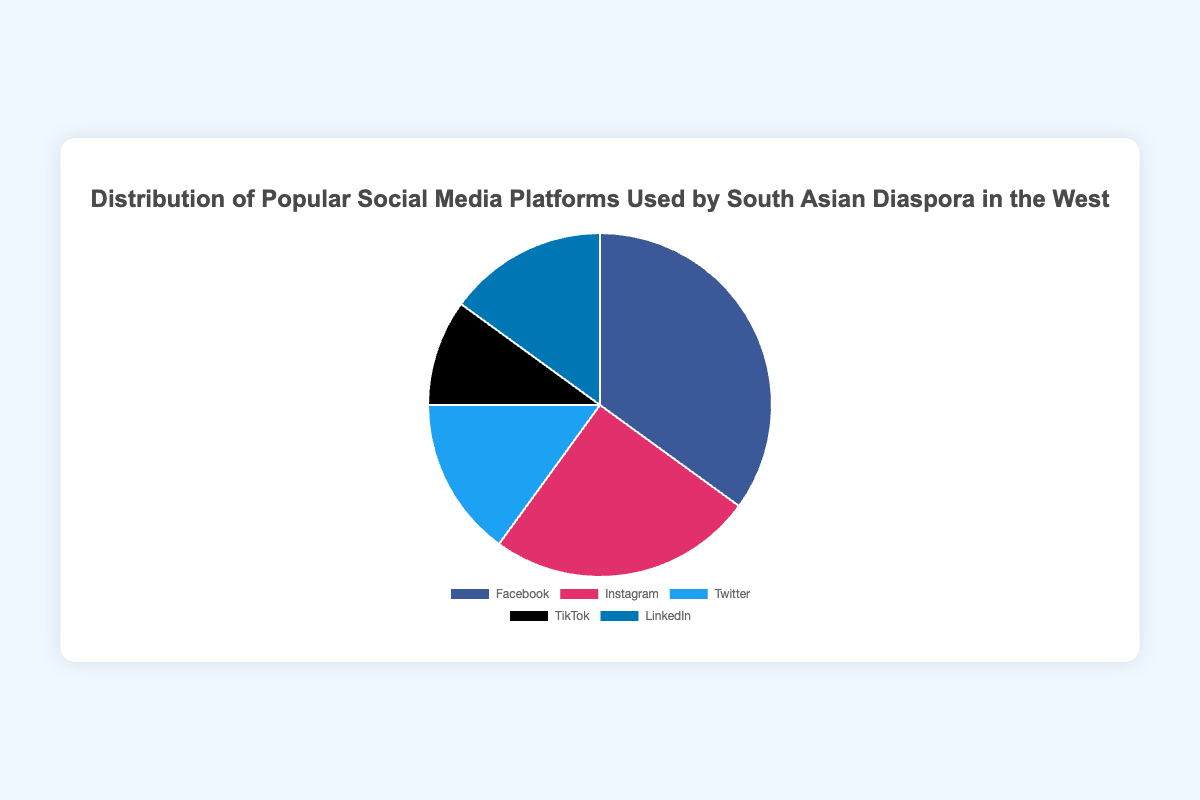What's the distribution of social media platforms in the pie chart? To find the distribution, we look at the percentage values shown in the pie chart for each platform: Facebook (35%), Instagram (25%), Twitter (15%), TikTok (10%), and LinkedIn (15%)
Answer: Facebook: 35%, Instagram: 25%, Twitter: 15%, TikTok: 10%, LinkedIn: 15% Which social media platform is the most popular among the South Asian diaspora in the West? The platform with the largest percentage slice in the pie chart is Facebook
Answer: Facebook What is the combined percentage of Twitter and LinkedIn usage? Adding the percentages for Twitter and LinkedIn gives 15% + 15% = 30%
Answer: 30% How much more popular is Facebook than Instagram? Subtract Instagram's percentage from Facebook's percentage: 35% - 25% = 10%
Answer: 10% Which social media platform has the smallest share? The platform with the smallest percentage slice in the pie chart is TikTok
Answer: TikTok If we combine the percentages of Instagram, Twitter, and TikTok, how does it compare to Facebook's percentage? Adding the percentages for Instagram, Twitter, and TikTok gives 25% + 15% + 10% = 50%. Comparing it to Facebook's 35%, we notice that 50% > 35%
Answer: 50% is greater than 35% Which platforms have an equal percentage share? In the pie chart, Twitter and LinkedIn both have a percentage of 15%
Answer: Twitter and LinkedIn What percentage of the South Asian diaspora uses Instagram compared to TikTok? Dividing Instagram's percentage by TikTok's percentage gives 25% / 10% = 2.5, meaning Instagram is 2.5 times as popular as TikTok
Answer: 2.5 times Compare the combined share of Facebook and TikTok to the combined share of Instagram and LinkedIn. Adding the percentages for Facebook and TikTok gives 35% + 10% = 45%. Adding the percentages for Instagram and LinkedIn gives 25% + 15% = 40%. So, 45% (Facebook and TikTok) > 40% (Instagram and LinkedIn)
Answer: 45% is greater than 40% 